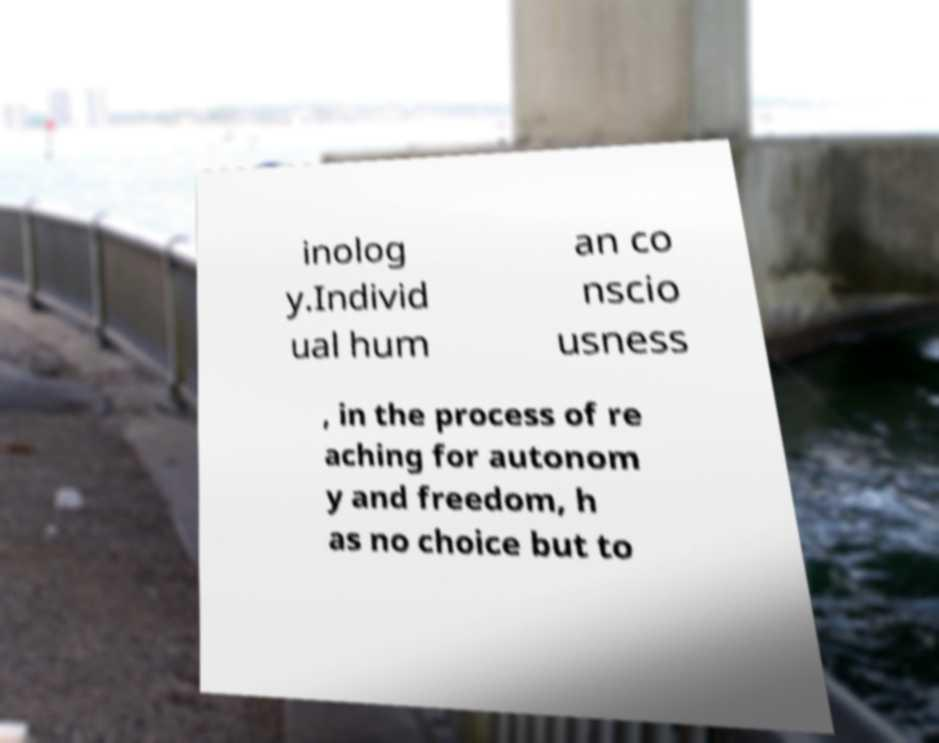What messages or text are displayed in this image? I need them in a readable, typed format. inolog y.Individ ual hum an co nscio usness , in the process of re aching for autonom y and freedom, h as no choice but to 